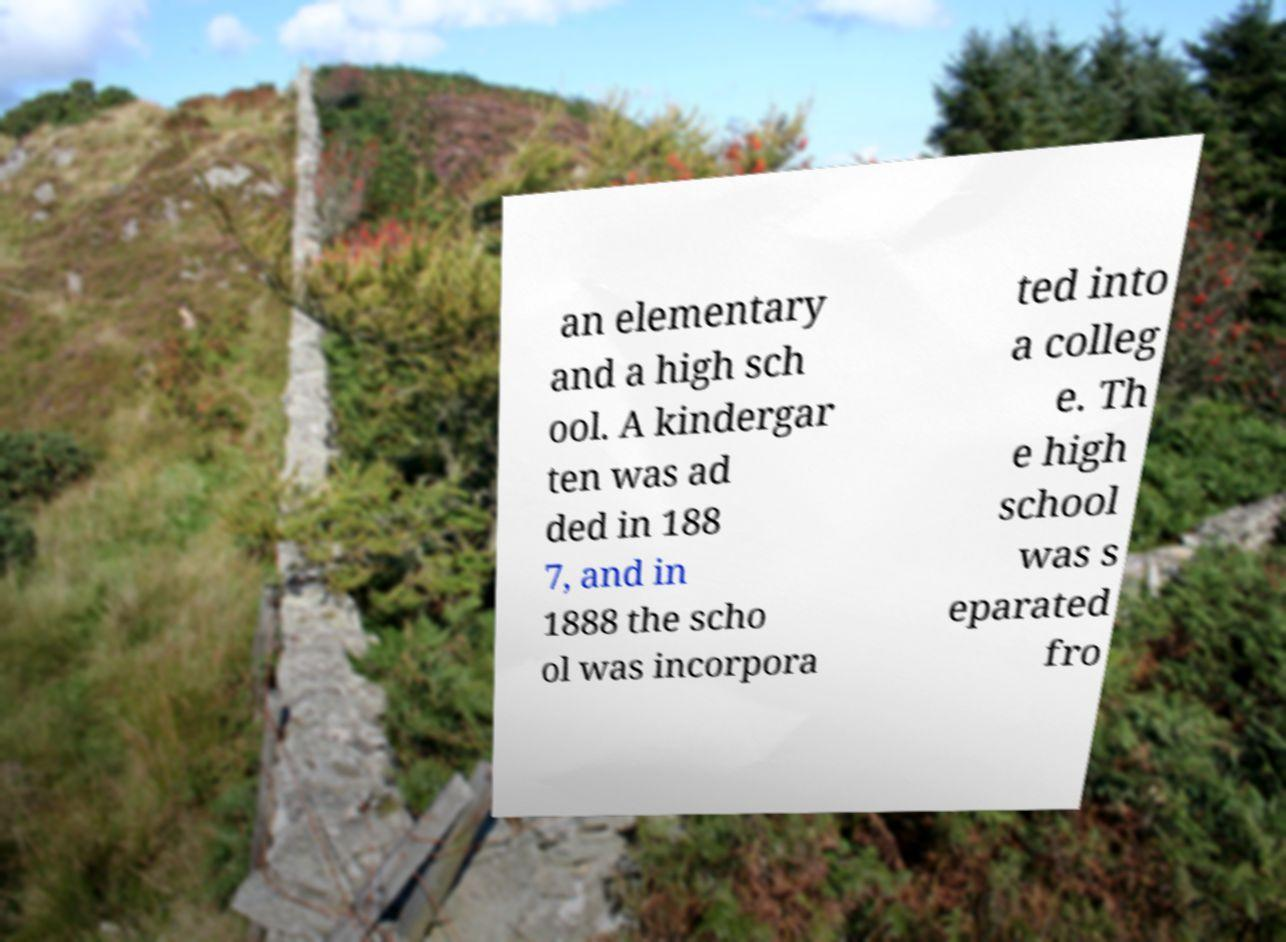I need the written content from this picture converted into text. Can you do that? an elementary and a high sch ool. A kindergar ten was ad ded in 188 7, and in 1888 the scho ol was incorpora ted into a colleg e. Th e high school was s eparated fro 